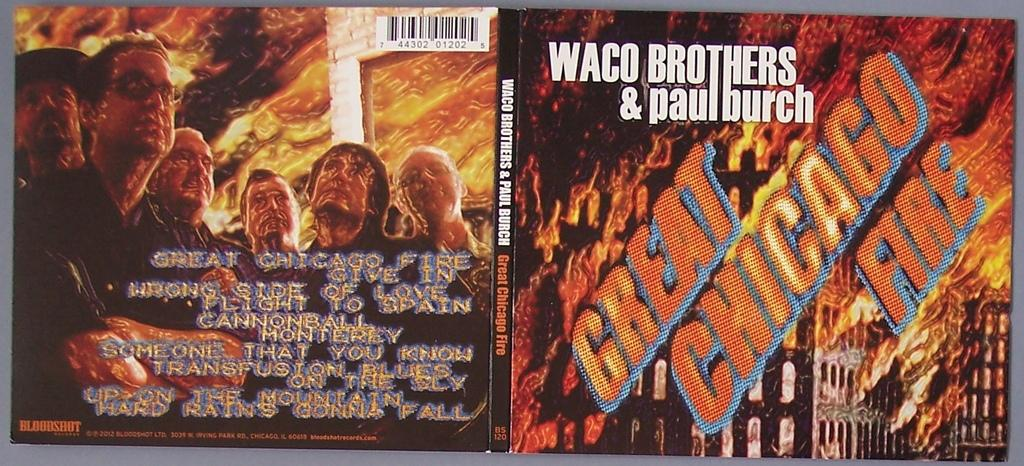<image>
Present a compact description of the photo's key features. a Great Chicago Fire album that is bright 